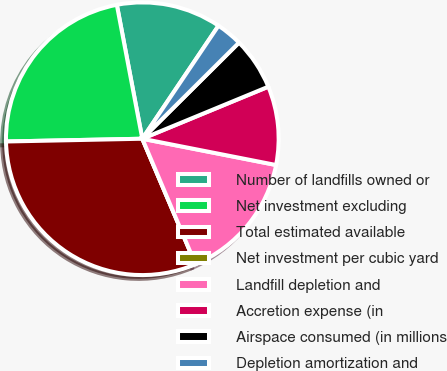<chart> <loc_0><loc_0><loc_500><loc_500><pie_chart><fcel>Number of landfills owned or<fcel>Net investment excluding<fcel>Total estimated available<fcel>Net investment per cubic yard<fcel>Landfill depletion and<fcel>Accretion expense (in<fcel>Airspace consumed (in millions<fcel>Depletion amortization and<nl><fcel>12.43%<fcel>22.33%<fcel>31.06%<fcel>0.0%<fcel>15.53%<fcel>9.32%<fcel>6.22%<fcel>3.11%<nl></chart> 